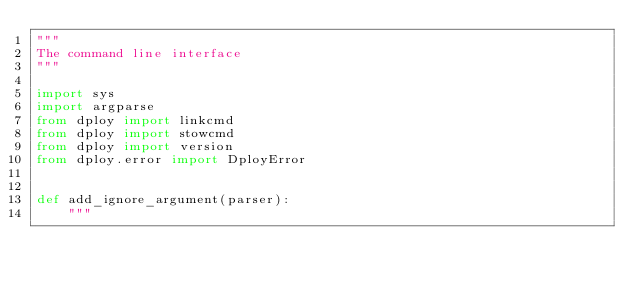Convert code to text. <code><loc_0><loc_0><loc_500><loc_500><_Python_>"""
The command line interface
"""

import sys
import argparse
from dploy import linkcmd
from dploy import stowcmd
from dploy import version
from dploy.error import DployError


def add_ignore_argument(parser):
    """</code> 